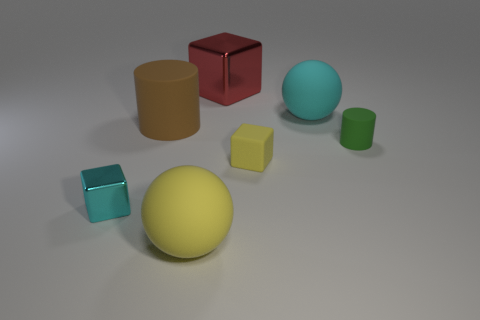Subtract all big red shiny blocks. How many blocks are left? 2 Add 2 small red objects. How many objects exist? 9 Subtract all cyan cubes. How many cubes are left? 2 Subtract all cubes. How many objects are left? 4 Subtract 2 balls. How many balls are left? 0 Subtract 0 gray spheres. How many objects are left? 7 Subtract all yellow spheres. Subtract all purple blocks. How many spheres are left? 1 Subtract all green balls. How many yellow cubes are left? 1 Subtract all tiny yellow matte things. Subtract all cyan cubes. How many objects are left? 5 Add 1 yellow rubber things. How many yellow rubber things are left? 3 